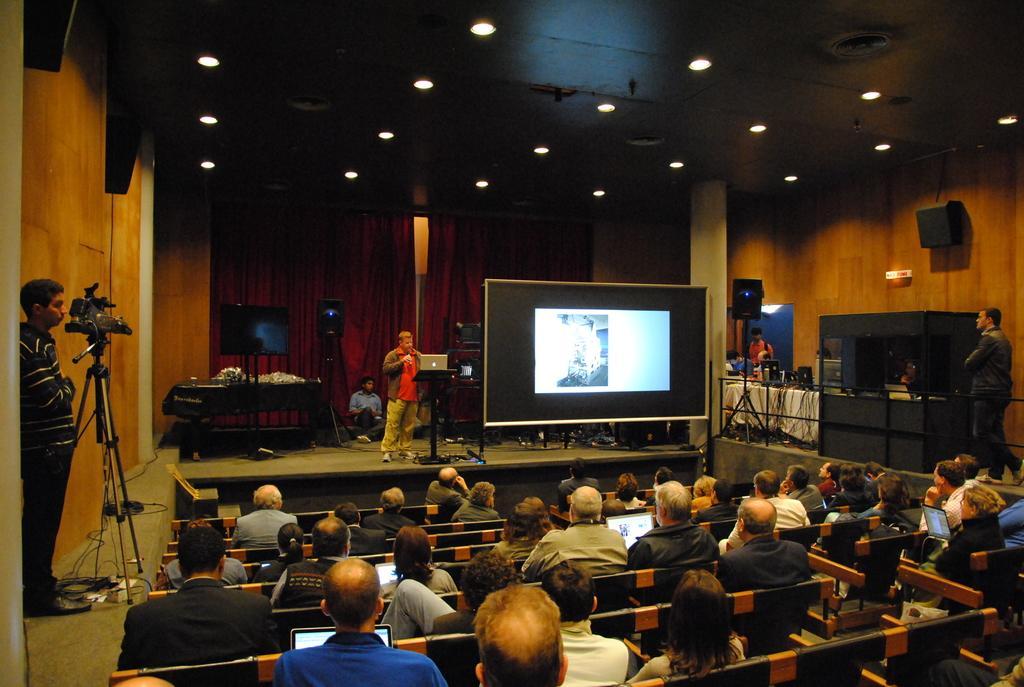In one or two sentences, can you explain what this image depicts? In the image there are many people sitting on the chairs looking at the screen in the front on the stage, beside it there is a man standing in front of laptop and on the left side there is a man standing in front of camera and above there are lights over the ceiling, on the background there is a tv with speakers in front of the curtain. 